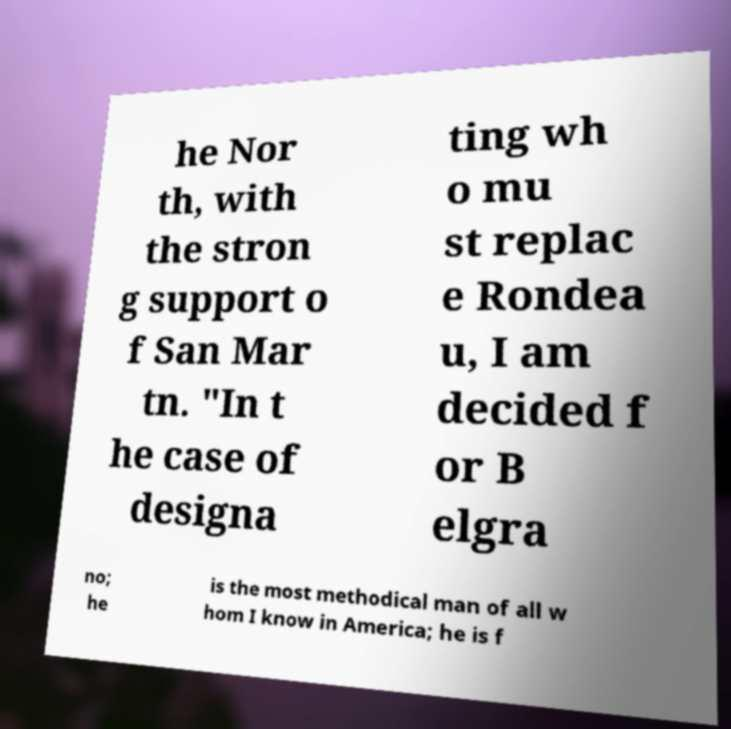There's text embedded in this image that I need extracted. Can you transcribe it verbatim? he Nor th, with the stron g support o f San Mar tn. "In t he case of designa ting wh o mu st replac e Rondea u, I am decided f or B elgra no; he is the most methodical man of all w hom I know in America; he is f 